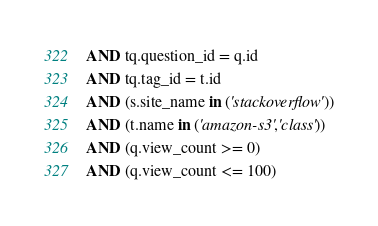<code> <loc_0><loc_0><loc_500><loc_500><_SQL_>AND tq.question_id = q.id
AND tq.tag_id = t.id
AND (s.site_name in ('stackoverflow'))
AND (t.name in ('amazon-s3','class'))
AND (q.view_count >= 0)
AND (q.view_count <= 100)
</code> 